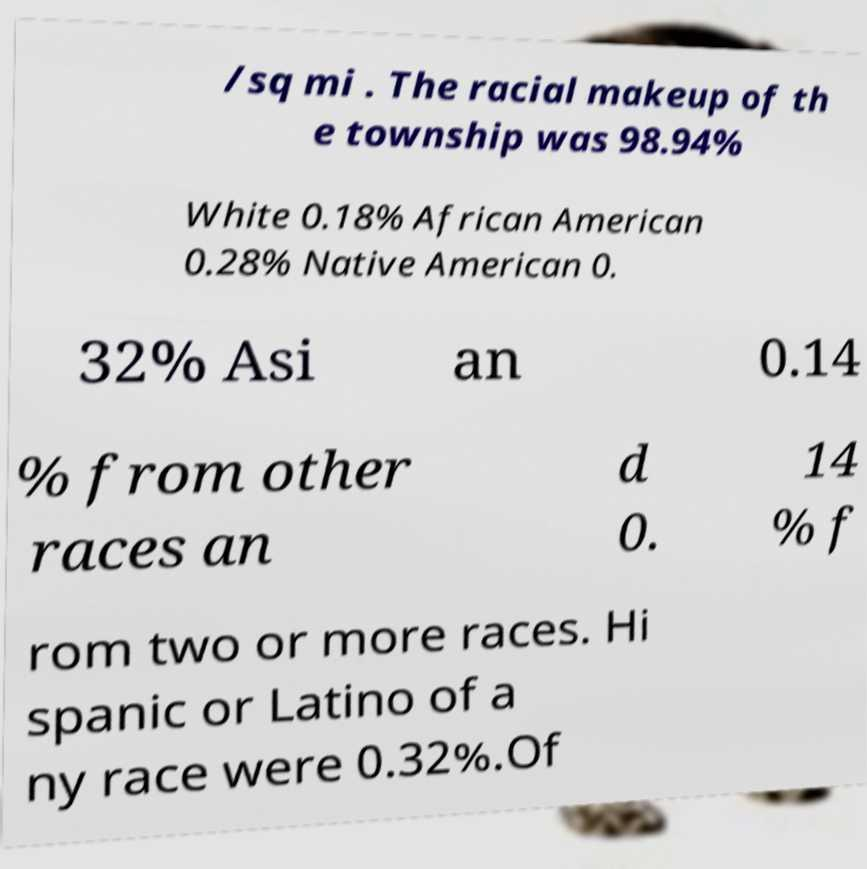Please identify and transcribe the text found in this image. /sq mi . The racial makeup of th e township was 98.94% White 0.18% African American 0.28% Native American 0. 32% Asi an 0.14 % from other races an d 0. 14 % f rom two or more races. Hi spanic or Latino of a ny race were 0.32%.Of 